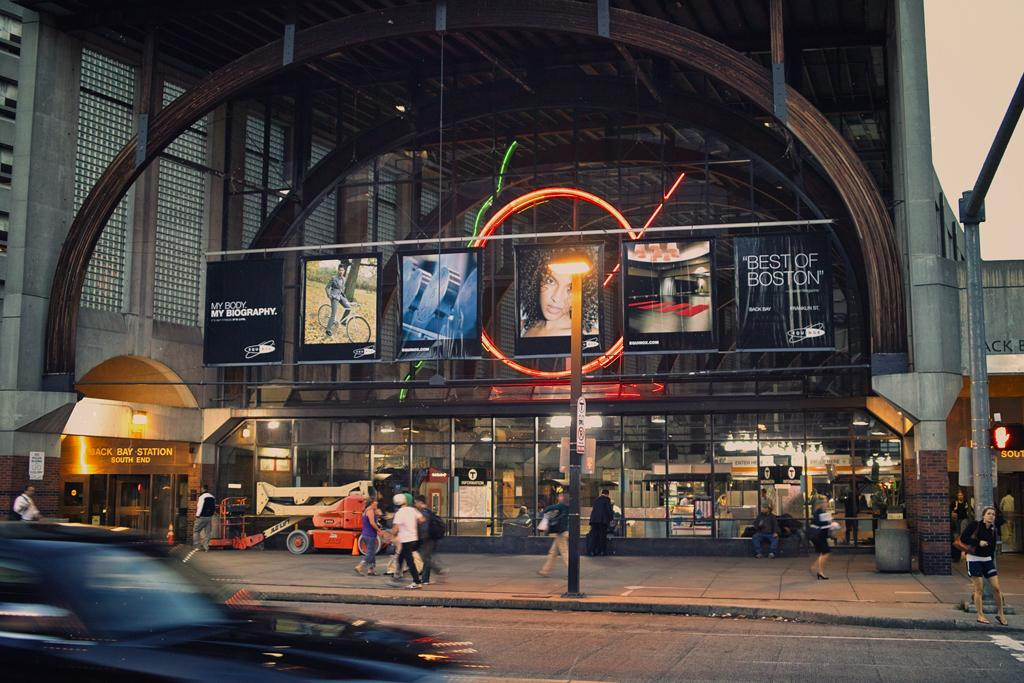What are the people in the image doing? The people in the image are walking. What can be seen illuminating the scene in the image? There is a street light in the image. What mode of transportation is present in the image? There is a car in the image. What type of structure is visible in the image? There is a building in the image. Can you tell me where the secretary is sitting in the image? There is no secretary present in the image. What type of tub can be seen in the image? There is no tub present in the image. 